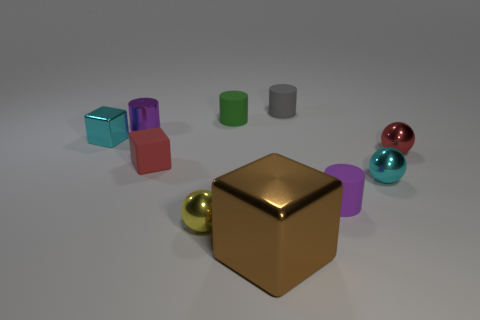Is there anything else that has the same size as the brown shiny block?
Make the answer very short. No. What is the shape of the tiny metal object that is the same color as the tiny matte block?
Give a very brief answer. Sphere. What is the shape of the gray rubber thing that is the same size as the purple shiny thing?
Your answer should be very brief. Cylinder. Are there fewer small red shiny objects than cyan metallic things?
Your answer should be compact. Yes. There is a metallic cube in front of the cyan cube; is there a small cyan thing that is to the left of it?
Make the answer very short. Yes. What is the shape of the purple object that is the same material as the gray thing?
Ensure brevity in your answer.  Cylinder. Is there any other thing that is the same color as the big cube?
Your response must be concise. No. What material is the red object that is the same shape as the yellow metal object?
Give a very brief answer. Metal. How many other objects are the same size as the green cylinder?
Keep it short and to the point. 8. The thing that is the same color as the tiny metal block is what size?
Offer a very short reply. Small. 